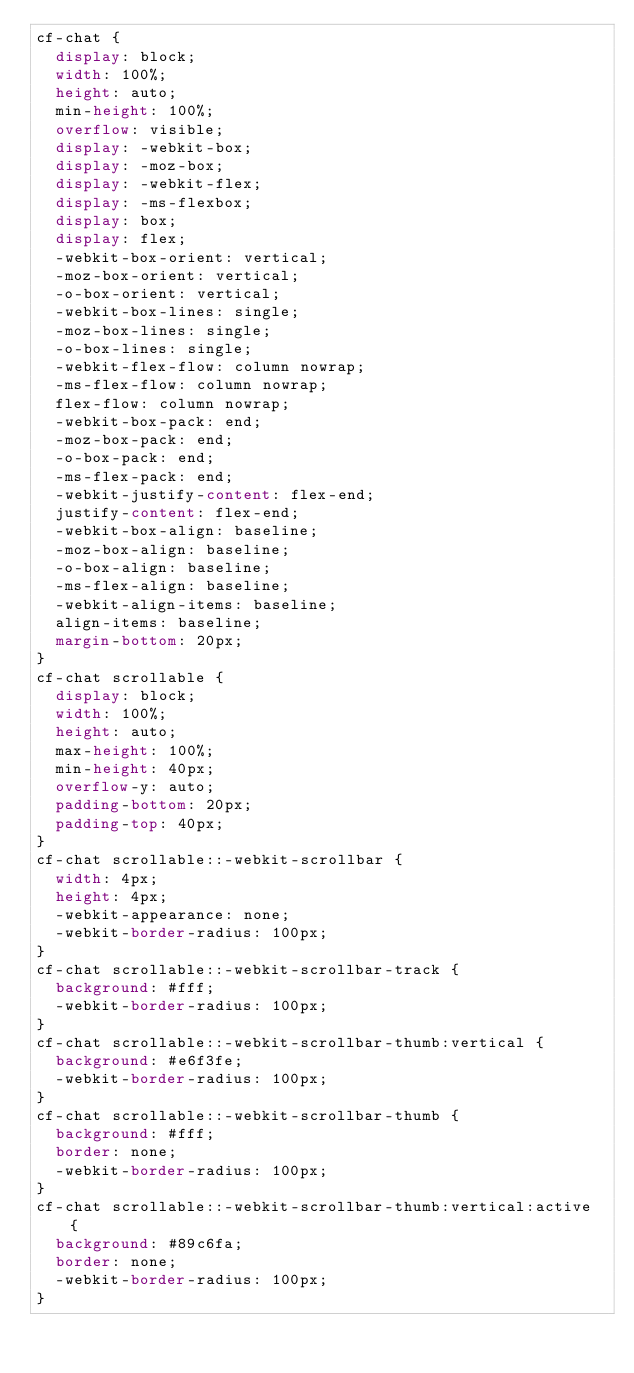<code> <loc_0><loc_0><loc_500><loc_500><_CSS_>cf-chat {
  display: block;
  width: 100%;
  height: auto;
  min-height: 100%;
  overflow: visible;
  display: -webkit-box;
  display: -moz-box;
  display: -webkit-flex;
  display: -ms-flexbox;
  display: box;
  display: flex;
  -webkit-box-orient: vertical;
  -moz-box-orient: vertical;
  -o-box-orient: vertical;
  -webkit-box-lines: single;
  -moz-box-lines: single;
  -o-box-lines: single;
  -webkit-flex-flow: column nowrap;
  -ms-flex-flow: column nowrap;
  flex-flow: column nowrap;
  -webkit-box-pack: end;
  -moz-box-pack: end;
  -o-box-pack: end;
  -ms-flex-pack: end;
  -webkit-justify-content: flex-end;
  justify-content: flex-end;
  -webkit-box-align: baseline;
  -moz-box-align: baseline;
  -o-box-align: baseline;
  -ms-flex-align: baseline;
  -webkit-align-items: baseline;
  align-items: baseline;
  margin-bottom: 20px;
}
cf-chat scrollable {
  display: block;
  width: 100%;
  height: auto;
  max-height: 100%;
  min-height: 40px;
  overflow-y: auto;
  padding-bottom: 20px;
  padding-top: 40px;
}
cf-chat scrollable::-webkit-scrollbar {
  width: 4px;
  height: 4px;
  -webkit-appearance: none;
  -webkit-border-radius: 100px;
}
cf-chat scrollable::-webkit-scrollbar-track {
  background: #fff;
  -webkit-border-radius: 100px;
}
cf-chat scrollable::-webkit-scrollbar-thumb:vertical {
  background: #e6f3fe;
  -webkit-border-radius: 100px;
}
cf-chat scrollable::-webkit-scrollbar-thumb {
  background: #fff;
  border: none;
  -webkit-border-radius: 100px;
}
cf-chat scrollable::-webkit-scrollbar-thumb:vertical:active {
  background: #89c6fa;
  border: none;
  -webkit-border-radius: 100px;
}
</code> 